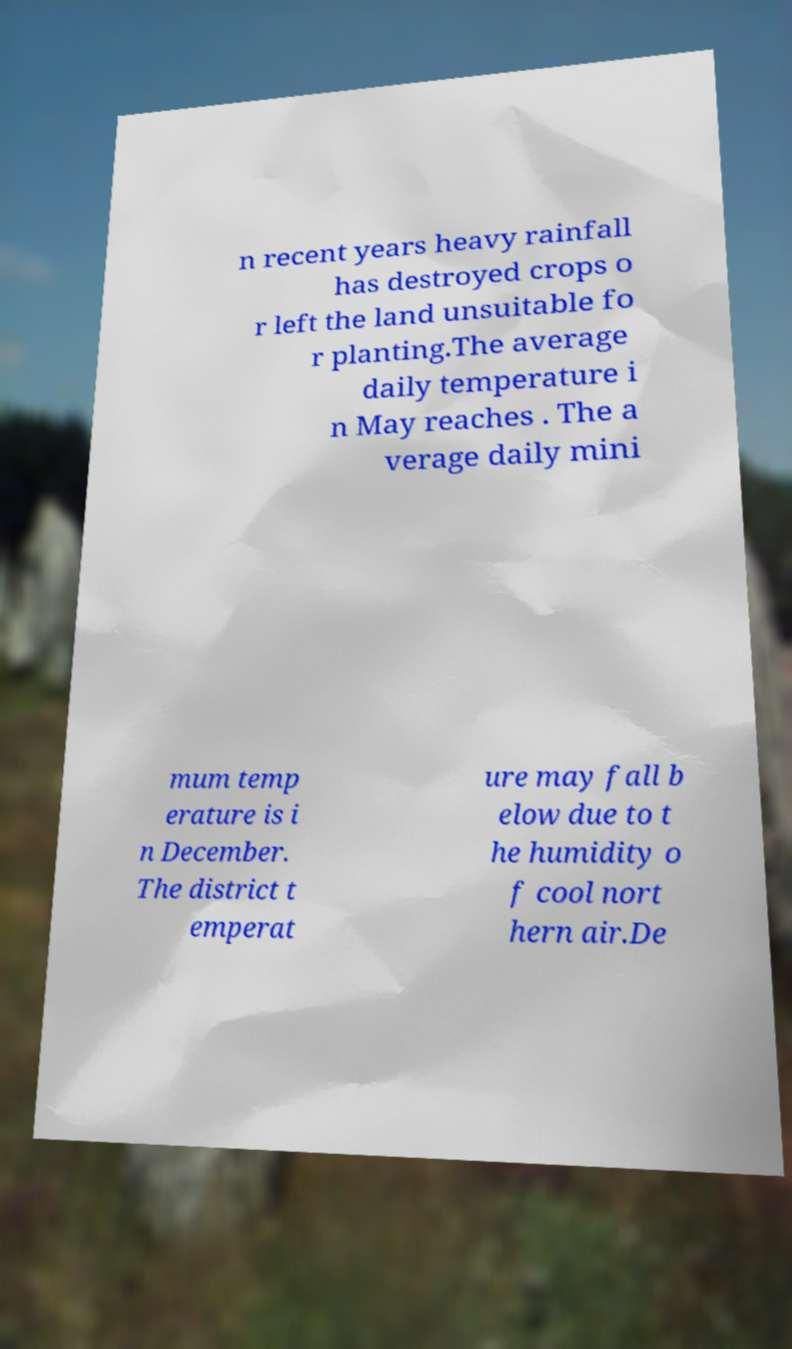Can you accurately transcribe the text from the provided image for me? n recent years heavy rainfall has destroyed crops o r left the land unsuitable fo r planting.The average daily temperature i n May reaches . The a verage daily mini mum temp erature is i n December. The district t emperat ure may fall b elow due to t he humidity o f cool nort hern air.De 